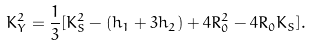Convert formula to latex. <formula><loc_0><loc_0><loc_500><loc_500>K _ { Y } ^ { 2 } = \frac { 1 } { 3 } [ K _ { S } ^ { 2 } - ( h _ { 1 } + 3 h _ { 2 } ) + 4 R _ { 0 } ^ { 2 } - 4 R _ { 0 } K _ { S } ] .</formula> 